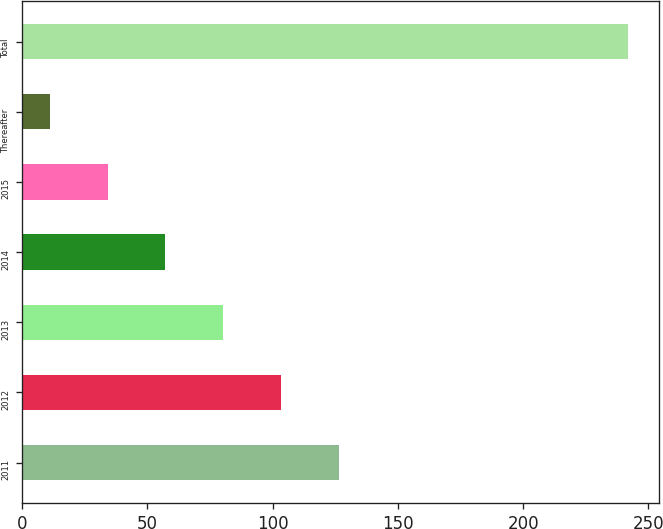<chart> <loc_0><loc_0><loc_500><loc_500><bar_chart><fcel>2011<fcel>2012<fcel>2013<fcel>2014<fcel>2015<fcel>Thereafter<fcel>Total<nl><fcel>126.5<fcel>103.4<fcel>80.3<fcel>57.2<fcel>34.1<fcel>11<fcel>242<nl></chart> 